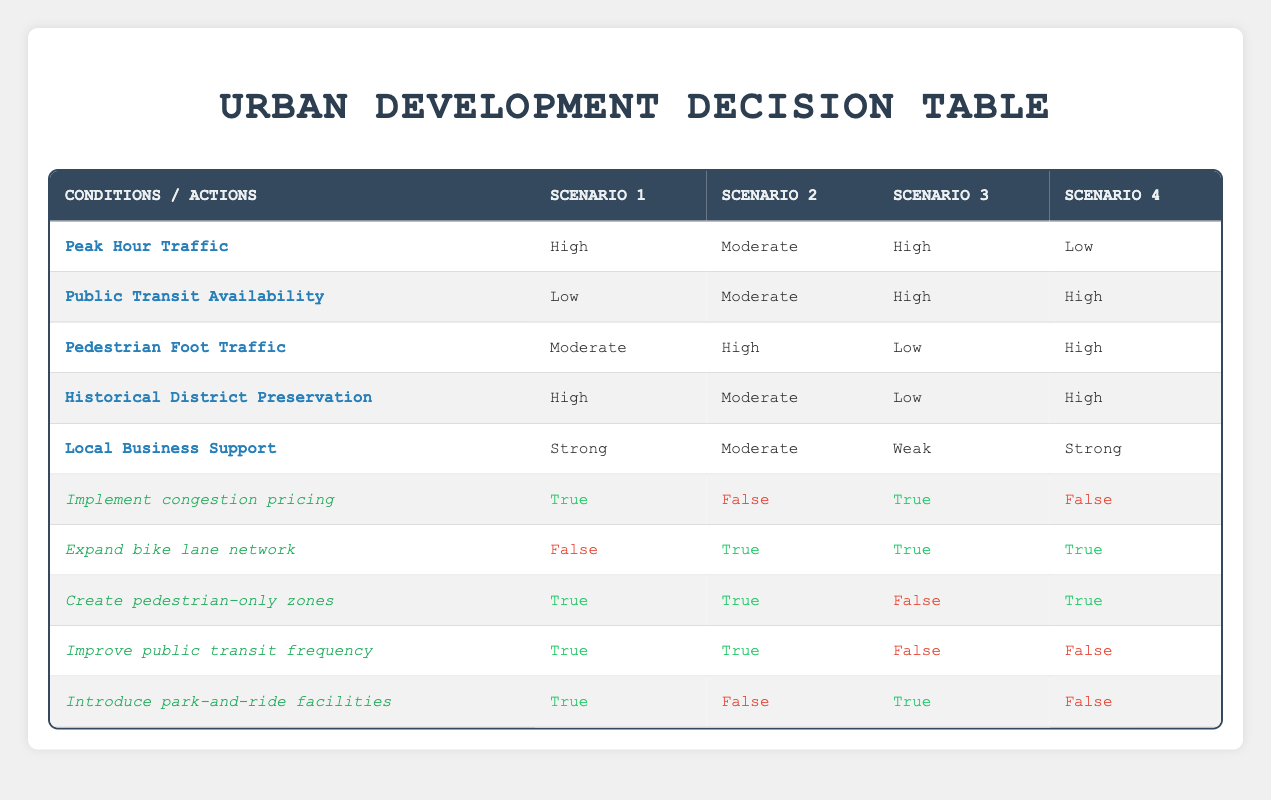What is the conditions when congestion pricing is implemented? Congestion pricing is implemented in Scenario 1 and Scenario 3. In Scenario 1, the conditions are High Peak Hour Traffic, Low Public Transit Availability, Moderate Pedestrian Foot Traffic, High Historical District Preservation, and Strong Local Business Support. In Scenario 3, the conditions are High Peak Hour Traffic, High Public Transit Availability, Low Pedestrian Foot Traffic, Low Historical District Preservation, and Weak Local Business Support.
Answer: Scenarios 1 and 3 How many scenarios support the expansion of the bike lane network? The bike lane network is expanded in Scenario 2, Scenario 3, and Scenario 4. Therefore, there are a total of three scenarios that support the action.
Answer: Three scenarios Is there any scenario where pedestrian-only zones are not created? In Scenario 3, although Peak Hour Traffic is high and Public Transit Availability is high, pedestrian-only zones are not created. In all other scenarios, pedestrian-only zones are created.
Answer: Yes, in Scenario 3 Which scenario has the highest total of favorable conditions for traffic management options? Scenario 1 has four favorable conditions: High Peak Hour Traffic, Low Public Transit Availability, Moderate Pedestrian Foot Traffic, High Historical District Preservation, and Strong Local Business Support. Compared to the others, it shows four positively weighted actions, making it the scenario with the most favorable conditions for traffic management solutions.
Answer: Scenario 1 What is the difference in the number of actions that are feasible between Scenario 1 and Scenario 2? Scenario 1 has four actions that are feasible while Scenario 2 has three feasible actions. The difference in the number of actions feasible between the two scenarios is one.
Answer: One action difference In which scenarios are park-and-ride facilities introduced? Park-and-ride facilities are introduced in Scenario 1 and Scenario 3. In both those scenarios, the conditions allow for their implementation.
Answer: Scenario 1 and 3 Do the scenarios with low pedestrian foot traffic always implement congestion pricing? Not necessarily. While Scenario 3 does feature low pedestrian foot traffic and implements congestion pricing, Scenario 1 with high pedestrian foot traffic also implements congestion pricing, indicating that low pedestrian flow does not guarantee congestion pricing will be enacted.
Answer: No What is the average number of favorable actions across all scenarios? Evaluating each scenario, we find that Scenario 1 has 4 favorable actions, Scenario 2 has 3, Scenario 3 has 3, and Scenario 4 has 3. This gives a total of 13 favorable actions across all scenarios. Therefore, the average is calculated by dividing the total by the number of scenarios, which yields 13/4 = 3.25.
Answer: 3.25 